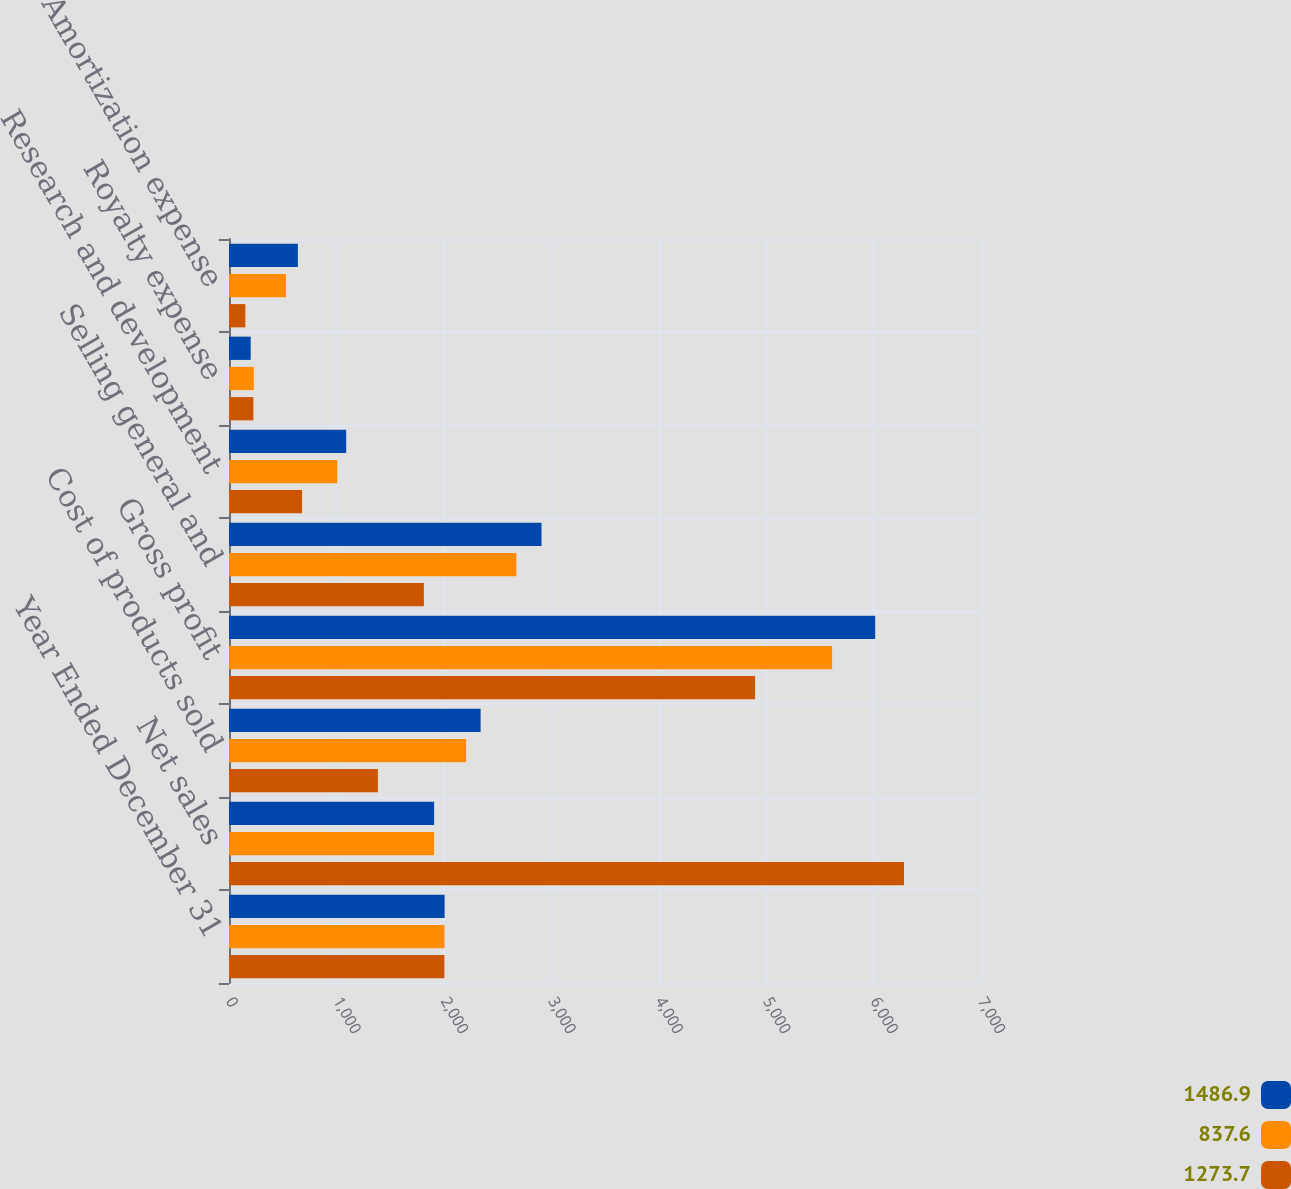<chart> <loc_0><loc_0><loc_500><loc_500><stacked_bar_chart><ecel><fcel>Year Ended December 31<fcel>Net sales<fcel>Cost of products sold<fcel>Gross profit<fcel>Selling general and<fcel>Research and development<fcel>Royalty expense<fcel>Amortization expense<nl><fcel>1486.9<fcel>2007<fcel>1909.5<fcel>2342<fcel>6015<fcel>2909<fcel>1091<fcel>202<fcel>641<nl><fcel>837.6<fcel>2006<fcel>1909.5<fcel>2207<fcel>5614<fcel>2675<fcel>1008<fcel>231<fcel>530<nl><fcel>1273.7<fcel>2005<fcel>6283<fcel>1386<fcel>4897<fcel>1814<fcel>680<fcel>227<fcel>152<nl></chart> 